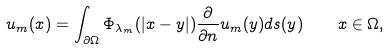Convert formula to latex. <formula><loc_0><loc_0><loc_500><loc_500>u _ { m } ( x ) = \int _ { \partial \Omega } \Phi _ { \lambda _ { m } } ( | x - y | ) \frac { \partial } { \partial n } u _ { m } ( y ) d s ( y ) \quad x \in \Omega ,</formula> 